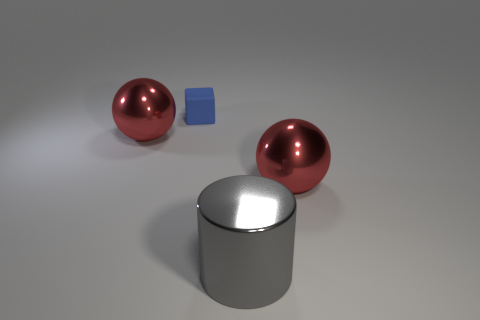There is a gray metal thing; is it the same size as the block behind the large metallic cylinder?
Your response must be concise. No. Do the gray cylinder and the blue object have the same size?
Provide a short and direct response. No. Is there any other thing that has the same color as the rubber object?
Your answer should be very brief. No. Is the shape of the blue object the same as the large gray shiny thing?
Offer a terse response. No. There is a metal ball on the left side of the red thing right of the big thing that is to the left of the blue rubber block; what size is it?
Keep it short and to the point. Large. What number of other objects are there of the same material as the large cylinder?
Ensure brevity in your answer.  2. What is the color of the metallic thing on the right side of the gray shiny thing?
Your response must be concise. Red. What is the material of the object that is behind the red metal object behind the large red object right of the gray cylinder?
Your answer should be compact. Rubber. What number of large balls are left of the matte cube and to the right of the small blue object?
Provide a succinct answer. 0. Are there fewer gray metallic objects in front of the large gray cylinder than cubes?
Offer a terse response. Yes. 